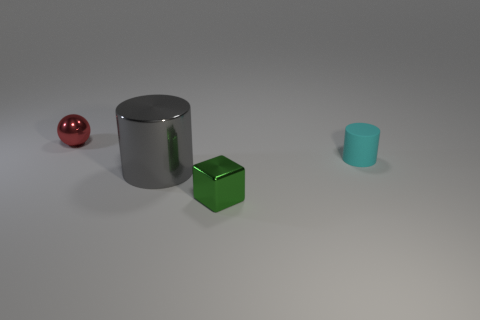Add 2 small green metal blocks. How many objects exist? 6 Subtract all blocks. How many objects are left? 3 Add 1 metal blocks. How many metal blocks exist? 2 Subtract 0 purple spheres. How many objects are left? 4 Subtract all gray things. Subtract all large things. How many objects are left? 2 Add 2 small balls. How many small balls are left? 3 